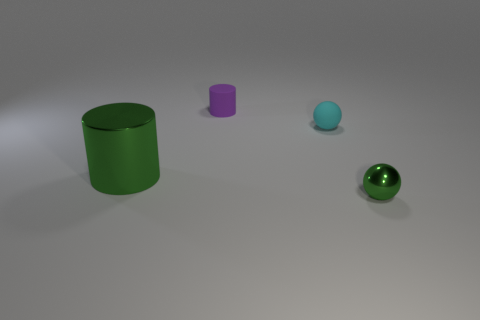What is the shape of the shiny object that is the same color as the small metallic sphere?
Your answer should be very brief. Cylinder. The shiny cylinder that is the same color as the tiny shiny ball is what size?
Give a very brief answer. Large. Does the small ball to the right of the cyan object have the same color as the big shiny thing?
Your response must be concise. Yes. How many big metallic things have the same color as the tiny metallic ball?
Offer a very short reply. 1. What is the material of the cyan ball that is the same size as the rubber cylinder?
Offer a very short reply. Rubber. Does the purple cylinder have the same size as the green metallic thing on the left side of the tiny purple rubber thing?
Your answer should be compact. No. There is a object that is in front of the metallic cylinder; what is its material?
Ensure brevity in your answer.  Metal. Are there the same number of cyan rubber objects that are left of the big green cylinder and tiny yellow shiny objects?
Keep it short and to the point. Yes. Does the green sphere have the same size as the green cylinder?
Make the answer very short. No. Is there a purple rubber object that is behind the small matte object behind the ball that is on the left side of the tiny metallic ball?
Offer a very short reply. No. 